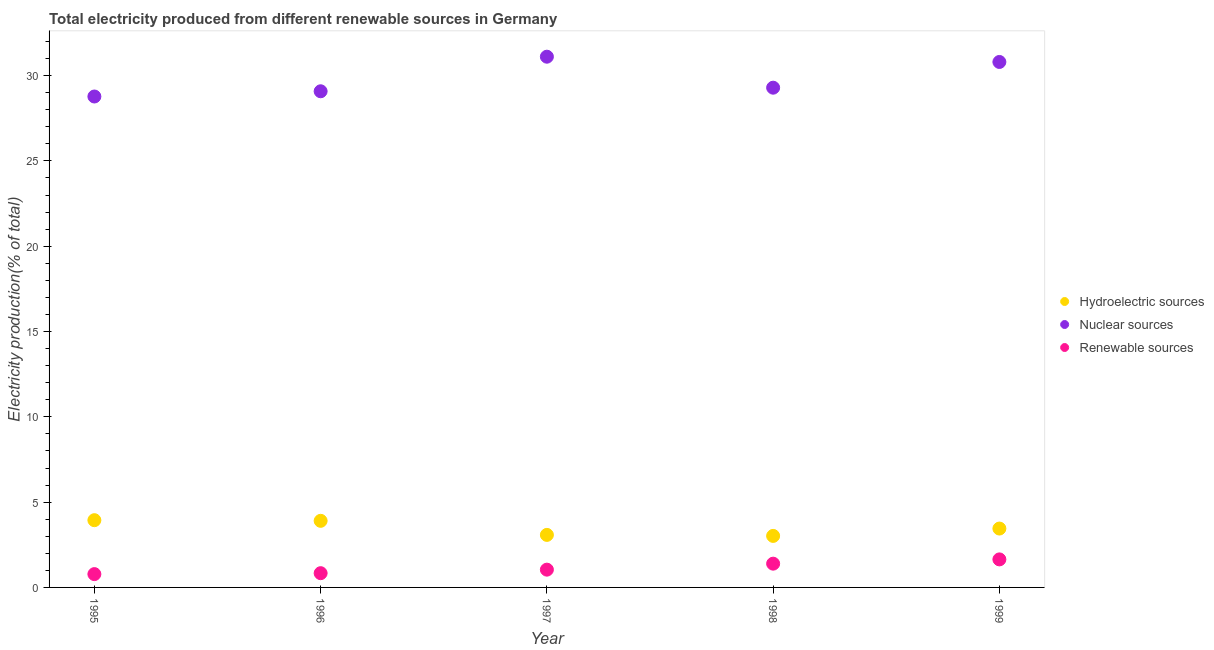How many different coloured dotlines are there?
Make the answer very short. 3. Is the number of dotlines equal to the number of legend labels?
Offer a terse response. Yes. What is the percentage of electricity produced by hydroelectric sources in 1997?
Make the answer very short. 3.08. Across all years, what is the maximum percentage of electricity produced by nuclear sources?
Ensure brevity in your answer.  31.11. Across all years, what is the minimum percentage of electricity produced by hydroelectric sources?
Your answer should be compact. 3.02. What is the total percentage of electricity produced by hydroelectric sources in the graph?
Your answer should be compact. 17.4. What is the difference between the percentage of electricity produced by renewable sources in 1997 and that in 1998?
Give a very brief answer. -0.35. What is the difference between the percentage of electricity produced by hydroelectric sources in 1996 and the percentage of electricity produced by nuclear sources in 1995?
Offer a very short reply. -24.87. What is the average percentage of electricity produced by nuclear sources per year?
Offer a terse response. 29.81. In the year 1997, what is the difference between the percentage of electricity produced by renewable sources and percentage of electricity produced by hydroelectric sources?
Offer a terse response. -2.04. What is the ratio of the percentage of electricity produced by nuclear sources in 1997 to that in 1998?
Make the answer very short. 1.06. Is the difference between the percentage of electricity produced by renewable sources in 1995 and 1999 greater than the difference between the percentage of electricity produced by hydroelectric sources in 1995 and 1999?
Provide a short and direct response. No. What is the difference between the highest and the second highest percentage of electricity produced by hydroelectric sources?
Give a very brief answer. 0.04. What is the difference between the highest and the lowest percentage of electricity produced by nuclear sources?
Ensure brevity in your answer.  2.33. Is the sum of the percentage of electricity produced by renewable sources in 1998 and 1999 greater than the maximum percentage of electricity produced by nuclear sources across all years?
Your response must be concise. No. Is it the case that in every year, the sum of the percentage of electricity produced by hydroelectric sources and percentage of electricity produced by nuclear sources is greater than the percentage of electricity produced by renewable sources?
Ensure brevity in your answer.  Yes. Is the percentage of electricity produced by renewable sources strictly greater than the percentage of electricity produced by hydroelectric sources over the years?
Give a very brief answer. No. How many dotlines are there?
Your response must be concise. 3. How many years are there in the graph?
Keep it short and to the point. 5. What is the difference between two consecutive major ticks on the Y-axis?
Provide a short and direct response. 5. Are the values on the major ticks of Y-axis written in scientific E-notation?
Offer a very short reply. No. How many legend labels are there?
Offer a terse response. 3. How are the legend labels stacked?
Provide a succinct answer. Vertical. What is the title of the graph?
Keep it short and to the point. Total electricity produced from different renewable sources in Germany. What is the label or title of the X-axis?
Provide a succinct answer. Year. What is the label or title of the Y-axis?
Your answer should be compact. Electricity production(% of total). What is the Electricity production(% of total) in Hydroelectric sources in 1995?
Make the answer very short. 3.94. What is the Electricity production(% of total) of Nuclear sources in 1995?
Provide a succinct answer. 28.78. What is the Electricity production(% of total) of Renewable sources in 1995?
Provide a short and direct response. 0.78. What is the Electricity production(% of total) in Hydroelectric sources in 1996?
Provide a succinct answer. 3.9. What is the Electricity production(% of total) in Nuclear sources in 1996?
Give a very brief answer. 29.08. What is the Electricity production(% of total) in Renewable sources in 1996?
Give a very brief answer. 0.83. What is the Electricity production(% of total) of Hydroelectric sources in 1997?
Your answer should be compact. 3.08. What is the Electricity production(% of total) in Nuclear sources in 1997?
Provide a short and direct response. 31.11. What is the Electricity production(% of total) in Renewable sources in 1997?
Provide a short and direct response. 1.04. What is the Electricity production(% of total) in Hydroelectric sources in 1998?
Make the answer very short. 3.02. What is the Electricity production(% of total) of Nuclear sources in 1998?
Offer a very short reply. 29.29. What is the Electricity production(% of total) of Renewable sources in 1998?
Make the answer very short. 1.39. What is the Electricity production(% of total) of Hydroelectric sources in 1999?
Give a very brief answer. 3.45. What is the Electricity production(% of total) in Nuclear sources in 1999?
Your answer should be very brief. 30.8. What is the Electricity production(% of total) of Renewable sources in 1999?
Give a very brief answer. 1.64. Across all years, what is the maximum Electricity production(% of total) of Hydroelectric sources?
Provide a short and direct response. 3.94. Across all years, what is the maximum Electricity production(% of total) in Nuclear sources?
Provide a short and direct response. 31.11. Across all years, what is the maximum Electricity production(% of total) of Renewable sources?
Offer a terse response. 1.64. Across all years, what is the minimum Electricity production(% of total) in Hydroelectric sources?
Offer a terse response. 3.02. Across all years, what is the minimum Electricity production(% of total) of Nuclear sources?
Provide a short and direct response. 28.78. Across all years, what is the minimum Electricity production(% of total) of Renewable sources?
Give a very brief answer. 0.78. What is the total Electricity production(% of total) in Hydroelectric sources in the graph?
Your answer should be very brief. 17.4. What is the total Electricity production(% of total) in Nuclear sources in the graph?
Your answer should be very brief. 149.06. What is the total Electricity production(% of total) in Renewable sources in the graph?
Ensure brevity in your answer.  5.69. What is the difference between the Electricity production(% of total) of Hydroelectric sources in 1995 and that in 1996?
Offer a terse response. 0.04. What is the difference between the Electricity production(% of total) of Nuclear sources in 1995 and that in 1996?
Your response must be concise. -0.31. What is the difference between the Electricity production(% of total) of Renewable sources in 1995 and that in 1996?
Offer a terse response. -0.05. What is the difference between the Electricity production(% of total) in Hydroelectric sources in 1995 and that in 1997?
Offer a terse response. 0.86. What is the difference between the Electricity production(% of total) in Nuclear sources in 1995 and that in 1997?
Offer a terse response. -2.33. What is the difference between the Electricity production(% of total) of Renewable sources in 1995 and that in 1997?
Make the answer very short. -0.26. What is the difference between the Electricity production(% of total) of Hydroelectric sources in 1995 and that in 1998?
Offer a very short reply. 0.92. What is the difference between the Electricity production(% of total) in Nuclear sources in 1995 and that in 1998?
Make the answer very short. -0.52. What is the difference between the Electricity production(% of total) in Renewable sources in 1995 and that in 1998?
Give a very brief answer. -0.61. What is the difference between the Electricity production(% of total) of Hydroelectric sources in 1995 and that in 1999?
Your response must be concise. 0.49. What is the difference between the Electricity production(% of total) of Nuclear sources in 1995 and that in 1999?
Make the answer very short. -2.02. What is the difference between the Electricity production(% of total) of Renewable sources in 1995 and that in 1999?
Offer a very short reply. -0.86. What is the difference between the Electricity production(% of total) of Hydroelectric sources in 1996 and that in 1997?
Provide a short and direct response. 0.82. What is the difference between the Electricity production(% of total) of Nuclear sources in 1996 and that in 1997?
Offer a very short reply. -2.03. What is the difference between the Electricity production(% of total) in Renewable sources in 1996 and that in 1997?
Give a very brief answer. -0.21. What is the difference between the Electricity production(% of total) in Hydroelectric sources in 1996 and that in 1998?
Ensure brevity in your answer.  0.88. What is the difference between the Electricity production(% of total) in Nuclear sources in 1996 and that in 1998?
Your answer should be compact. -0.21. What is the difference between the Electricity production(% of total) in Renewable sources in 1996 and that in 1998?
Keep it short and to the point. -0.56. What is the difference between the Electricity production(% of total) in Hydroelectric sources in 1996 and that in 1999?
Provide a succinct answer. 0.45. What is the difference between the Electricity production(% of total) of Nuclear sources in 1996 and that in 1999?
Give a very brief answer. -1.72. What is the difference between the Electricity production(% of total) of Renewable sources in 1996 and that in 1999?
Offer a very short reply. -0.81. What is the difference between the Electricity production(% of total) of Hydroelectric sources in 1997 and that in 1998?
Your response must be concise. 0.06. What is the difference between the Electricity production(% of total) of Nuclear sources in 1997 and that in 1998?
Offer a very short reply. 1.82. What is the difference between the Electricity production(% of total) in Renewable sources in 1997 and that in 1998?
Provide a succinct answer. -0.35. What is the difference between the Electricity production(% of total) of Hydroelectric sources in 1997 and that in 1999?
Ensure brevity in your answer.  -0.37. What is the difference between the Electricity production(% of total) of Nuclear sources in 1997 and that in 1999?
Provide a succinct answer. 0.31. What is the difference between the Electricity production(% of total) in Renewable sources in 1997 and that in 1999?
Offer a terse response. -0.6. What is the difference between the Electricity production(% of total) of Hydroelectric sources in 1998 and that in 1999?
Provide a short and direct response. -0.43. What is the difference between the Electricity production(% of total) of Nuclear sources in 1998 and that in 1999?
Offer a terse response. -1.51. What is the difference between the Electricity production(% of total) in Renewable sources in 1998 and that in 1999?
Provide a short and direct response. -0.25. What is the difference between the Electricity production(% of total) in Hydroelectric sources in 1995 and the Electricity production(% of total) in Nuclear sources in 1996?
Your response must be concise. -25.14. What is the difference between the Electricity production(% of total) of Hydroelectric sources in 1995 and the Electricity production(% of total) of Renewable sources in 1996?
Offer a terse response. 3.11. What is the difference between the Electricity production(% of total) in Nuclear sources in 1995 and the Electricity production(% of total) in Renewable sources in 1996?
Provide a short and direct response. 27.94. What is the difference between the Electricity production(% of total) of Hydroelectric sources in 1995 and the Electricity production(% of total) of Nuclear sources in 1997?
Give a very brief answer. -27.17. What is the difference between the Electricity production(% of total) in Hydroelectric sources in 1995 and the Electricity production(% of total) in Renewable sources in 1997?
Give a very brief answer. 2.9. What is the difference between the Electricity production(% of total) in Nuclear sources in 1995 and the Electricity production(% of total) in Renewable sources in 1997?
Your answer should be very brief. 27.73. What is the difference between the Electricity production(% of total) of Hydroelectric sources in 1995 and the Electricity production(% of total) of Nuclear sources in 1998?
Offer a terse response. -25.35. What is the difference between the Electricity production(% of total) in Hydroelectric sources in 1995 and the Electricity production(% of total) in Renewable sources in 1998?
Give a very brief answer. 2.55. What is the difference between the Electricity production(% of total) in Nuclear sources in 1995 and the Electricity production(% of total) in Renewable sources in 1998?
Your answer should be very brief. 27.38. What is the difference between the Electricity production(% of total) in Hydroelectric sources in 1995 and the Electricity production(% of total) in Nuclear sources in 1999?
Keep it short and to the point. -26.86. What is the difference between the Electricity production(% of total) of Hydroelectric sources in 1995 and the Electricity production(% of total) of Renewable sources in 1999?
Give a very brief answer. 2.3. What is the difference between the Electricity production(% of total) of Nuclear sources in 1995 and the Electricity production(% of total) of Renewable sources in 1999?
Your response must be concise. 27.13. What is the difference between the Electricity production(% of total) of Hydroelectric sources in 1996 and the Electricity production(% of total) of Nuclear sources in 1997?
Your answer should be compact. -27.21. What is the difference between the Electricity production(% of total) of Hydroelectric sources in 1996 and the Electricity production(% of total) of Renewable sources in 1997?
Provide a short and direct response. 2.86. What is the difference between the Electricity production(% of total) of Nuclear sources in 1996 and the Electricity production(% of total) of Renewable sources in 1997?
Your answer should be very brief. 28.04. What is the difference between the Electricity production(% of total) in Hydroelectric sources in 1996 and the Electricity production(% of total) in Nuclear sources in 1998?
Offer a terse response. -25.39. What is the difference between the Electricity production(% of total) of Hydroelectric sources in 1996 and the Electricity production(% of total) of Renewable sources in 1998?
Ensure brevity in your answer.  2.51. What is the difference between the Electricity production(% of total) in Nuclear sources in 1996 and the Electricity production(% of total) in Renewable sources in 1998?
Make the answer very short. 27.69. What is the difference between the Electricity production(% of total) in Hydroelectric sources in 1996 and the Electricity production(% of total) in Nuclear sources in 1999?
Keep it short and to the point. -26.9. What is the difference between the Electricity production(% of total) in Hydroelectric sources in 1996 and the Electricity production(% of total) in Renewable sources in 1999?
Offer a very short reply. 2.26. What is the difference between the Electricity production(% of total) in Nuclear sources in 1996 and the Electricity production(% of total) in Renewable sources in 1999?
Keep it short and to the point. 27.44. What is the difference between the Electricity production(% of total) of Hydroelectric sources in 1997 and the Electricity production(% of total) of Nuclear sources in 1998?
Keep it short and to the point. -26.21. What is the difference between the Electricity production(% of total) of Hydroelectric sources in 1997 and the Electricity production(% of total) of Renewable sources in 1998?
Your answer should be compact. 1.69. What is the difference between the Electricity production(% of total) in Nuclear sources in 1997 and the Electricity production(% of total) in Renewable sources in 1998?
Offer a very short reply. 29.72. What is the difference between the Electricity production(% of total) of Hydroelectric sources in 1997 and the Electricity production(% of total) of Nuclear sources in 1999?
Ensure brevity in your answer.  -27.72. What is the difference between the Electricity production(% of total) of Hydroelectric sources in 1997 and the Electricity production(% of total) of Renewable sources in 1999?
Ensure brevity in your answer.  1.44. What is the difference between the Electricity production(% of total) of Nuclear sources in 1997 and the Electricity production(% of total) of Renewable sources in 1999?
Provide a short and direct response. 29.47. What is the difference between the Electricity production(% of total) in Hydroelectric sources in 1998 and the Electricity production(% of total) in Nuclear sources in 1999?
Ensure brevity in your answer.  -27.78. What is the difference between the Electricity production(% of total) in Hydroelectric sources in 1998 and the Electricity production(% of total) in Renewable sources in 1999?
Ensure brevity in your answer.  1.38. What is the difference between the Electricity production(% of total) of Nuclear sources in 1998 and the Electricity production(% of total) of Renewable sources in 1999?
Your response must be concise. 27.65. What is the average Electricity production(% of total) of Hydroelectric sources per year?
Offer a very short reply. 3.48. What is the average Electricity production(% of total) of Nuclear sources per year?
Provide a short and direct response. 29.81. What is the average Electricity production(% of total) of Renewable sources per year?
Offer a very short reply. 1.14. In the year 1995, what is the difference between the Electricity production(% of total) in Hydroelectric sources and Electricity production(% of total) in Nuclear sources?
Your answer should be very brief. -24.83. In the year 1995, what is the difference between the Electricity production(% of total) of Hydroelectric sources and Electricity production(% of total) of Renewable sources?
Your answer should be very brief. 3.16. In the year 1995, what is the difference between the Electricity production(% of total) of Nuclear sources and Electricity production(% of total) of Renewable sources?
Offer a very short reply. 28. In the year 1996, what is the difference between the Electricity production(% of total) in Hydroelectric sources and Electricity production(% of total) in Nuclear sources?
Make the answer very short. -25.18. In the year 1996, what is the difference between the Electricity production(% of total) of Hydroelectric sources and Electricity production(% of total) of Renewable sources?
Give a very brief answer. 3.07. In the year 1996, what is the difference between the Electricity production(% of total) in Nuclear sources and Electricity production(% of total) in Renewable sources?
Offer a very short reply. 28.25. In the year 1997, what is the difference between the Electricity production(% of total) in Hydroelectric sources and Electricity production(% of total) in Nuclear sources?
Make the answer very short. -28.03. In the year 1997, what is the difference between the Electricity production(% of total) in Hydroelectric sources and Electricity production(% of total) in Renewable sources?
Your answer should be very brief. 2.04. In the year 1997, what is the difference between the Electricity production(% of total) in Nuclear sources and Electricity production(% of total) in Renewable sources?
Offer a terse response. 30.07. In the year 1998, what is the difference between the Electricity production(% of total) of Hydroelectric sources and Electricity production(% of total) of Nuclear sources?
Provide a short and direct response. -26.27. In the year 1998, what is the difference between the Electricity production(% of total) of Hydroelectric sources and Electricity production(% of total) of Renewable sources?
Provide a short and direct response. 1.63. In the year 1998, what is the difference between the Electricity production(% of total) of Nuclear sources and Electricity production(% of total) of Renewable sources?
Give a very brief answer. 27.9. In the year 1999, what is the difference between the Electricity production(% of total) in Hydroelectric sources and Electricity production(% of total) in Nuclear sources?
Provide a short and direct response. -27.35. In the year 1999, what is the difference between the Electricity production(% of total) in Hydroelectric sources and Electricity production(% of total) in Renewable sources?
Ensure brevity in your answer.  1.81. In the year 1999, what is the difference between the Electricity production(% of total) in Nuclear sources and Electricity production(% of total) in Renewable sources?
Make the answer very short. 29.16. What is the ratio of the Electricity production(% of total) in Hydroelectric sources in 1995 to that in 1996?
Provide a succinct answer. 1.01. What is the ratio of the Electricity production(% of total) in Renewable sources in 1995 to that in 1996?
Your answer should be very brief. 0.93. What is the ratio of the Electricity production(% of total) of Hydroelectric sources in 1995 to that in 1997?
Offer a very short reply. 1.28. What is the ratio of the Electricity production(% of total) of Nuclear sources in 1995 to that in 1997?
Provide a short and direct response. 0.93. What is the ratio of the Electricity production(% of total) of Renewable sources in 1995 to that in 1997?
Offer a very short reply. 0.75. What is the ratio of the Electricity production(% of total) in Hydroelectric sources in 1995 to that in 1998?
Ensure brevity in your answer.  1.31. What is the ratio of the Electricity production(% of total) in Nuclear sources in 1995 to that in 1998?
Your answer should be very brief. 0.98. What is the ratio of the Electricity production(% of total) of Renewable sources in 1995 to that in 1998?
Make the answer very short. 0.56. What is the ratio of the Electricity production(% of total) of Hydroelectric sources in 1995 to that in 1999?
Ensure brevity in your answer.  1.14. What is the ratio of the Electricity production(% of total) in Nuclear sources in 1995 to that in 1999?
Provide a succinct answer. 0.93. What is the ratio of the Electricity production(% of total) in Renewable sources in 1995 to that in 1999?
Give a very brief answer. 0.47. What is the ratio of the Electricity production(% of total) of Hydroelectric sources in 1996 to that in 1997?
Offer a terse response. 1.27. What is the ratio of the Electricity production(% of total) of Nuclear sources in 1996 to that in 1997?
Keep it short and to the point. 0.93. What is the ratio of the Electricity production(% of total) of Renewable sources in 1996 to that in 1997?
Give a very brief answer. 0.8. What is the ratio of the Electricity production(% of total) in Hydroelectric sources in 1996 to that in 1998?
Your answer should be compact. 1.29. What is the ratio of the Electricity production(% of total) of Renewable sources in 1996 to that in 1998?
Your answer should be very brief. 0.6. What is the ratio of the Electricity production(% of total) of Hydroelectric sources in 1996 to that in 1999?
Offer a very short reply. 1.13. What is the ratio of the Electricity production(% of total) in Nuclear sources in 1996 to that in 1999?
Provide a succinct answer. 0.94. What is the ratio of the Electricity production(% of total) of Renewable sources in 1996 to that in 1999?
Give a very brief answer. 0.51. What is the ratio of the Electricity production(% of total) of Hydroelectric sources in 1997 to that in 1998?
Provide a short and direct response. 1.02. What is the ratio of the Electricity production(% of total) in Nuclear sources in 1997 to that in 1998?
Offer a very short reply. 1.06. What is the ratio of the Electricity production(% of total) of Renewable sources in 1997 to that in 1998?
Make the answer very short. 0.75. What is the ratio of the Electricity production(% of total) in Hydroelectric sources in 1997 to that in 1999?
Your response must be concise. 0.89. What is the ratio of the Electricity production(% of total) in Renewable sources in 1997 to that in 1999?
Provide a short and direct response. 0.63. What is the ratio of the Electricity production(% of total) in Hydroelectric sources in 1998 to that in 1999?
Your response must be concise. 0.88. What is the ratio of the Electricity production(% of total) in Nuclear sources in 1998 to that in 1999?
Offer a terse response. 0.95. What is the ratio of the Electricity production(% of total) of Renewable sources in 1998 to that in 1999?
Make the answer very short. 0.85. What is the difference between the highest and the second highest Electricity production(% of total) of Hydroelectric sources?
Make the answer very short. 0.04. What is the difference between the highest and the second highest Electricity production(% of total) in Nuclear sources?
Your answer should be compact. 0.31. What is the difference between the highest and the second highest Electricity production(% of total) of Renewable sources?
Offer a terse response. 0.25. What is the difference between the highest and the lowest Electricity production(% of total) of Hydroelectric sources?
Offer a terse response. 0.92. What is the difference between the highest and the lowest Electricity production(% of total) in Nuclear sources?
Offer a terse response. 2.33. What is the difference between the highest and the lowest Electricity production(% of total) in Renewable sources?
Your response must be concise. 0.86. 